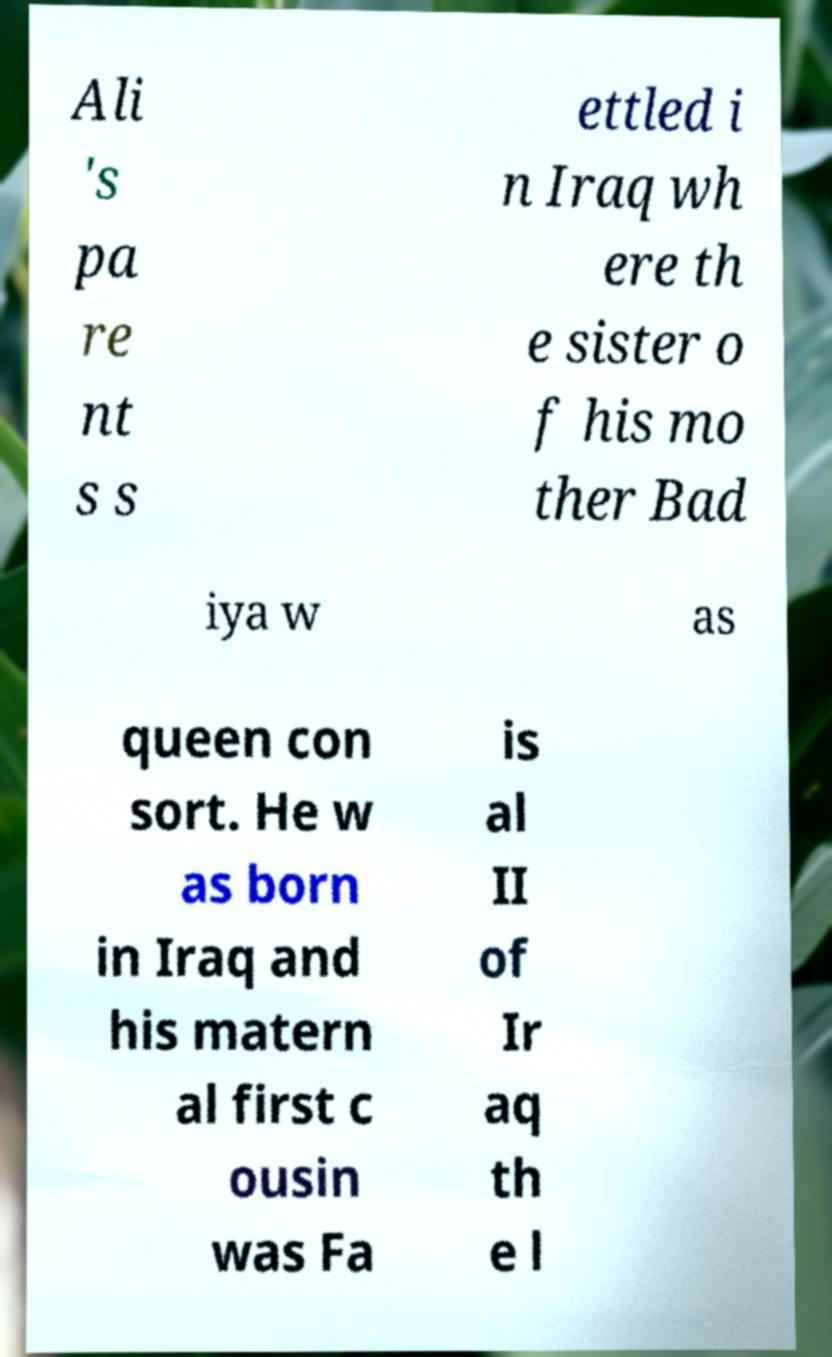Please identify and transcribe the text found in this image. Ali 's pa re nt s s ettled i n Iraq wh ere th e sister o f his mo ther Bad iya w as queen con sort. He w as born in Iraq and his matern al first c ousin was Fa is al II of Ir aq th e l 